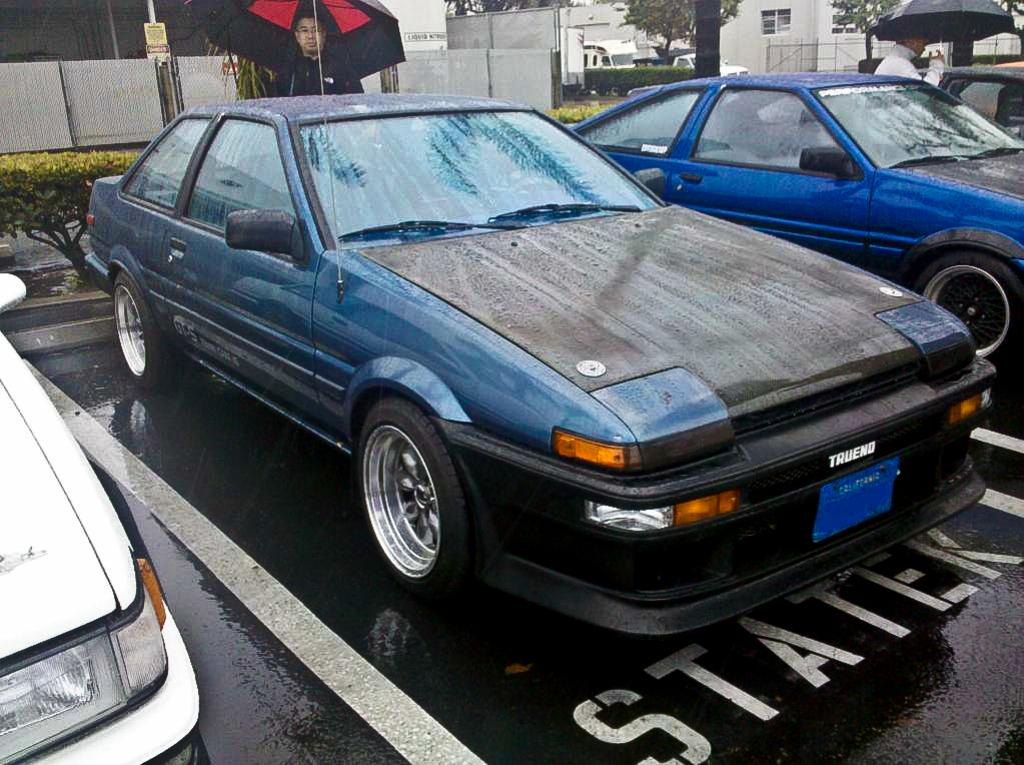What type of vehicles can be seen in the image? There are cars in the image. What are the two persons holding to protect themselves from the weather? They are holding umbrellas. What is the background of the image composed of? There is a wall and a building in the image. Is there any greenery visible in the image? Yes, there is a plant in the top left of the image. What type of nut is being used as a door handle in the image? There is no nut being used as a door handle in the image; it is a regular door without any visible nuts. 